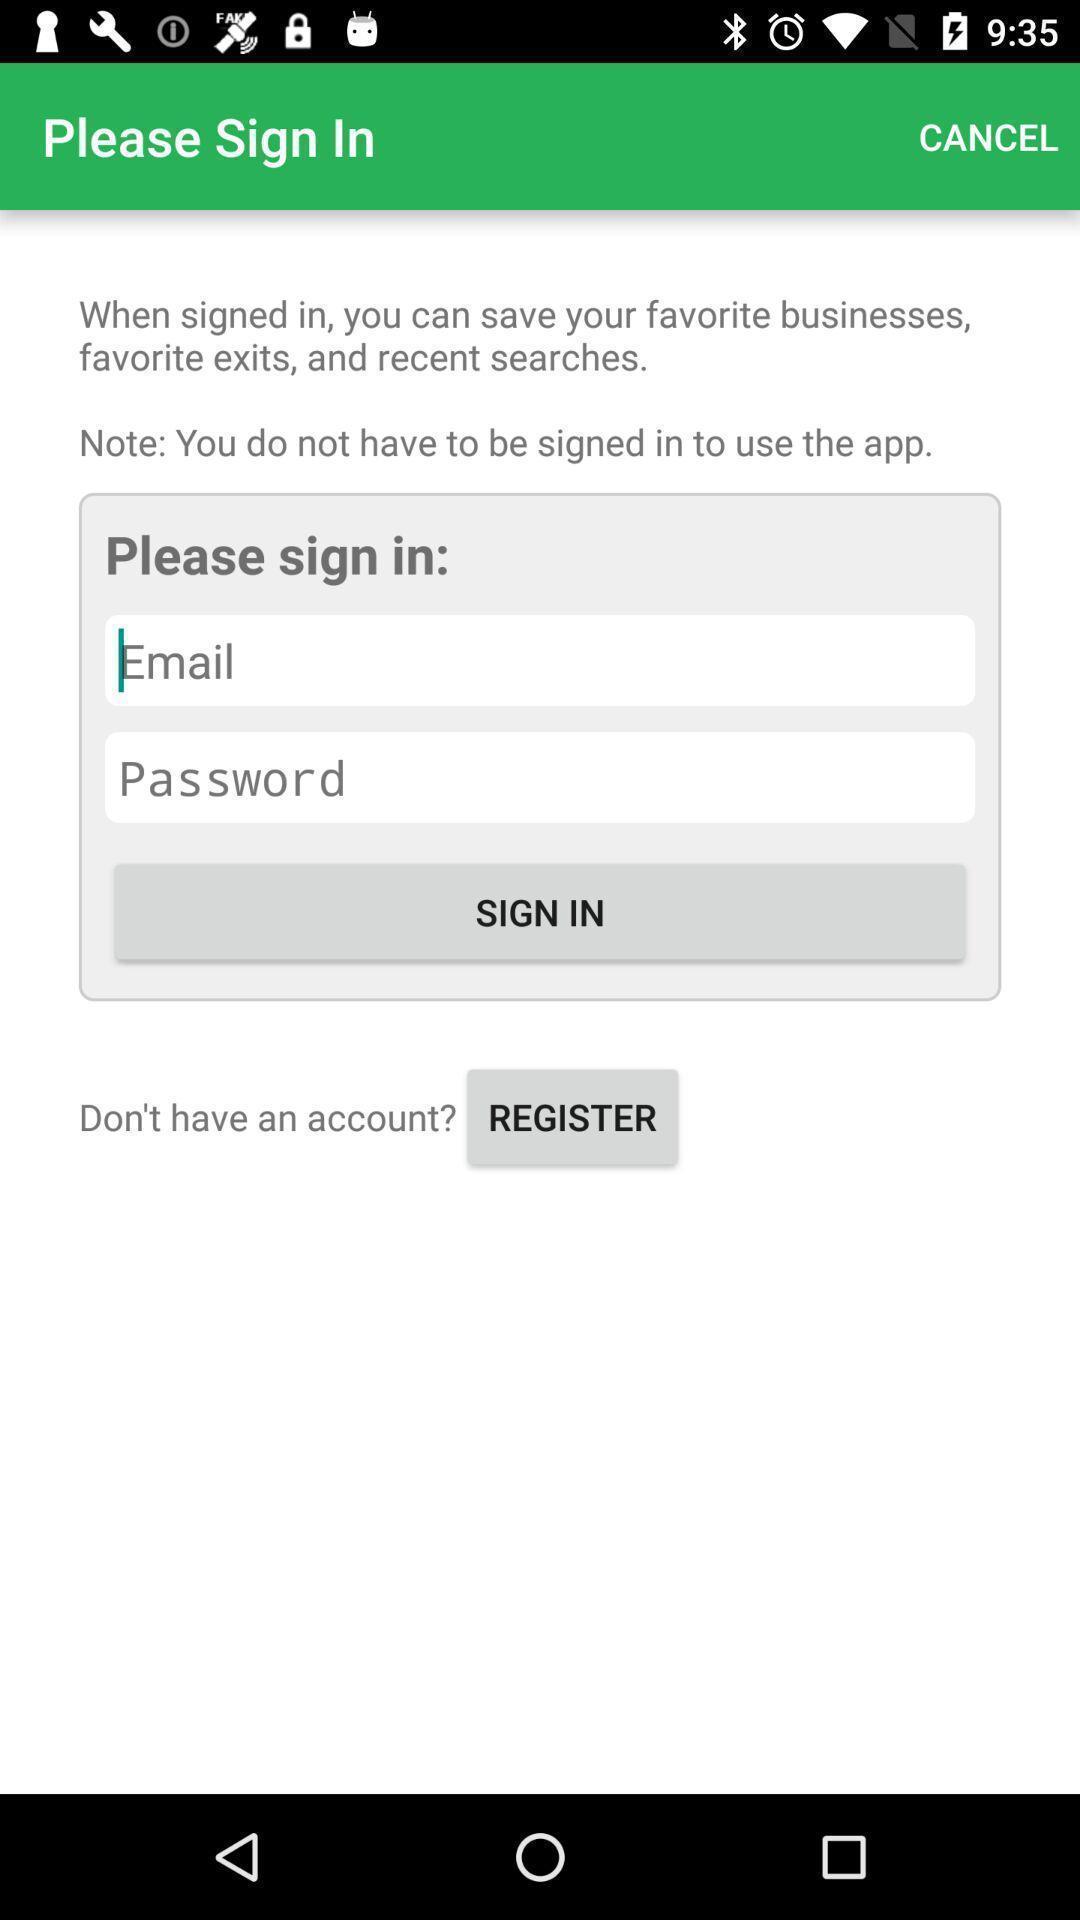Explain the elements present in this screenshot. Sign-in page. 